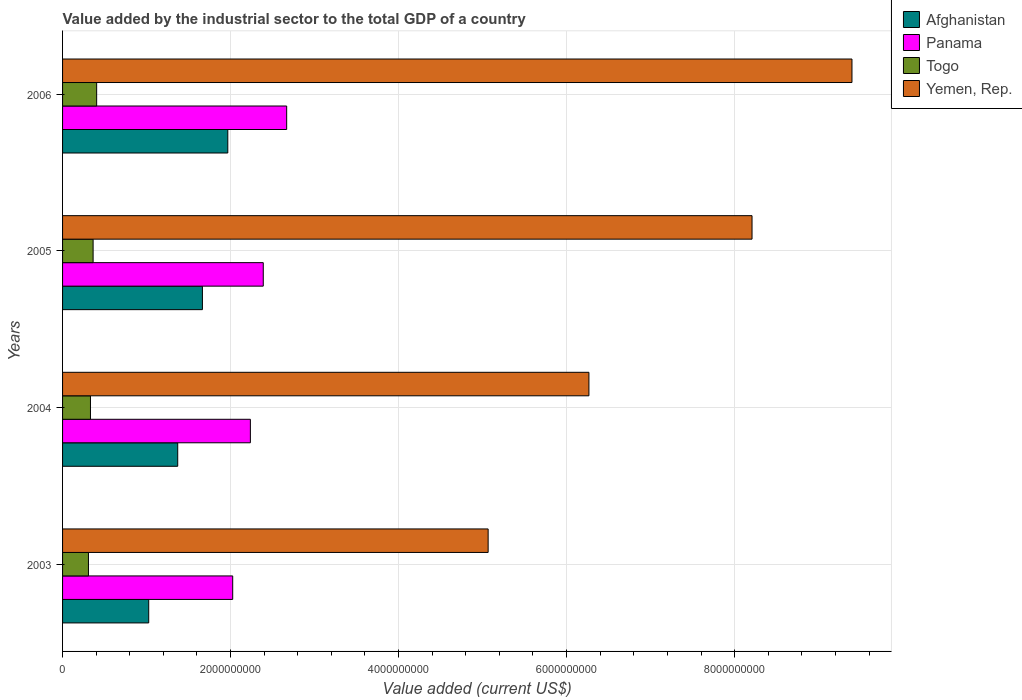What is the value added by the industrial sector to the total GDP in Yemen, Rep. in 2006?
Your answer should be very brief. 9.40e+09. Across all years, what is the maximum value added by the industrial sector to the total GDP in Afghanistan?
Make the answer very short. 1.97e+09. Across all years, what is the minimum value added by the industrial sector to the total GDP in Togo?
Keep it short and to the point. 3.08e+08. In which year was the value added by the industrial sector to the total GDP in Afghanistan minimum?
Keep it short and to the point. 2003. What is the total value added by the industrial sector to the total GDP in Afghanistan in the graph?
Provide a short and direct response. 6.03e+09. What is the difference between the value added by the industrial sector to the total GDP in Afghanistan in 2004 and that in 2005?
Offer a terse response. -2.94e+08. What is the difference between the value added by the industrial sector to the total GDP in Afghanistan in 2004 and the value added by the industrial sector to the total GDP in Togo in 2003?
Ensure brevity in your answer.  1.06e+09. What is the average value added by the industrial sector to the total GDP in Panama per year?
Your answer should be compact. 2.33e+09. In the year 2004, what is the difference between the value added by the industrial sector to the total GDP in Yemen, Rep. and value added by the industrial sector to the total GDP in Togo?
Make the answer very short. 5.93e+09. In how many years, is the value added by the industrial sector to the total GDP in Afghanistan greater than 9200000000 US$?
Make the answer very short. 0. What is the ratio of the value added by the industrial sector to the total GDP in Togo in 2003 to that in 2006?
Provide a succinct answer. 0.76. What is the difference between the highest and the second highest value added by the industrial sector to the total GDP in Afghanistan?
Your answer should be compact. 3.02e+08. What is the difference between the highest and the lowest value added by the industrial sector to the total GDP in Afghanistan?
Give a very brief answer. 9.41e+08. Is the sum of the value added by the industrial sector to the total GDP in Togo in 2003 and 2006 greater than the maximum value added by the industrial sector to the total GDP in Yemen, Rep. across all years?
Offer a terse response. No. Is it the case that in every year, the sum of the value added by the industrial sector to the total GDP in Panama and value added by the industrial sector to the total GDP in Afghanistan is greater than the sum of value added by the industrial sector to the total GDP in Yemen, Rep. and value added by the industrial sector to the total GDP in Togo?
Provide a succinct answer. Yes. What does the 3rd bar from the top in 2003 represents?
Make the answer very short. Panama. What does the 1st bar from the bottom in 2006 represents?
Provide a short and direct response. Afghanistan. Are the values on the major ticks of X-axis written in scientific E-notation?
Provide a succinct answer. No. Does the graph contain any zero values?
Your response must be concise. No. How are the legend labels stacked?
Keep it short and to the point. Vertical. What is the title of the graph?
Offer a terse response. Value added by the industrial sector to the total GDP of a country. What is the label or title of the X-axis?
Provide a succinct answer. Value added (current US$). What is the Value added (current US$) in Afghanistan in 2003?
Ensure brevity in your answer.  1.03e+09. What is the Value added (current US$) of Panama in 2003?
Offer a terse response. 2.03e+09. What is the Value added (current US$) in Togo in 2003?
Make the answer very short. 3.08e+08. What is the Value added (current US$) in Yemen, Rep. in 2003?
Your response must be concise. 5.07e+09. What is the Value added (current US$) of Afghanistan in 2004?
Provide a succinct answer. 1.37e+09. What is the Value added (current US$) in Panama in 2004?
Make the answer very short. 2.24e+09. What is the Value added (current US$) of Togo in 2004?
Provide a succinct answer. 3.32e+08. What is the Value added (current US$) of Yemen, Rep. in 2004?
Give a very brief answer. 6.27e+09. What is the Value added (current US$) in Afghanistan in 2005?
Provide a succinct answer. 1.66e+09. What is the Value added (current US$) in Panama in 2005?
Give a very brief answer. 2.39e+09. What is the Value added (current US$) in Togo in 2005?
Provide a short and direct response. 3.64e+08. What is the Value added (current US$) in Yemen, Rep. in 2005?
Your response must be concise. 8.21e+09. What is the Value added (current US$) of Afghanistan in 2006?
Your answer should be compact. 1.97e+09. What is the Value added (current US$) of Panama in 2006?
Provide a short and direct response. 2.67e+09. What is the Value added (current US$) of Togo in 2006?
Your response must be concise. 4.06e+08. What is the Value added (current US$) in Yemen, Rep. in 2006?
Make the answer very short. 9.40e+09. Across all years, what is the maximum Value added (current US$) of Afghanistan?
Offer a terse response. 1.97e+09. Across all years, what is the maximum Value added (current US$) of Panama?
Offer a very short reply. 2.67e+09. Across all years, what is the maximum Value added (current US$) of Togo?
Your answer should be compact. 4.06e+08. Across all years, what is the maximum Value added (current US$) of Yemen, Rep.?
Your answer should be compact. 9.40e+09. Across all years, what is the minimum Value added (current US$) of Afghanistan?
Provide a short and direct response. 1.03e+09. Across all years, what is the minimum Value added (current US$) of Panama?
Ensure brevity in your answer.  2.03e+09. Across all years, what is the minimum Value added (current US$) of Togo?
Provide a short and direct response. 3.08e+08. Across all years, what is the minimum Value added (current US$) in Yemen, Rep.?
Your answer should be compact. 5.07e+09. What is the total Value added (current US$) in Afghanistan in the graph?
Your response must be concise. 6.03e+09. What is the total Value added (current US$) of Panama in the graph?
Make the answer very short. 9.32e+09. What is the total Value added (current US$) of Togo in the graph?
Provide a succinct answer. 1.41e+09. What is the total Value added (current US$) of Yemen, Rep. in the graph?
Provide a short and direct response. 2.89e+1. What is the difference between the Value added (current US$) of Afghanistan in 2003 and that in 2004?
Keep it short and to the point. -3.45e+08. What is the difference between the Value added (current US$) of Panama in 2003 and that in 2004?
Your answer should be compact. -2.10e+08. What is the difference between the Value added (current US$) in Togo in 2003 and that in 2004?
Your answer should be very brief. -2.40e+07. What is the difference between the Value added (current US$) of Yemen, Rep. in 2003 and that in 2004?
Make the answer very short. -1.20e+09. What is the difference between the Value added (current US$) of Afghanistan in 2003 and that in 2005?
Provide a short and direct response. -6.39e+08. What is the difference between the Value added (current US$) of Panama in 2003 and that in 2005?
Provide a short and direct response. -3.64e+08. What is the difference between the Value added (current US$) in Togo in 2003 and that in 2005?
Give a very brief answer. -5.54e+07. What is the difference between the Value added (current US$) in Yemen, Rep. in 2003 and that in 2005?
Your response must be concise. -3.14e+09. What is the difference between the Value added (current US$) of Afghanistan in 2003 and that in 2006?
Give a very brief answer. -9.41e+08. What is the difference between the Value added (current US$) of Panama in 2003 and that in 2006?
Your answer should be very brief. -6.42e+08. What is the difference between the Value added (current US$) of Togo in 2003 and that in 2006?
Keep it short and to the point. -9.77e+07. What is the difference between the Value added (current US$) in Yemen, Rep. in 2003 and that in 2006?
Your answer should be compact. -4.33e+09. What is the difference between the Value added (current US$) in Afghanistan in 2004 and that in 2005?
Your answer should be compact. -2.94e+08. What is the difference between the Value added (current US$) in Panama in 2004 and that in 2005?
Give a very brief answer. -1.53e+08. What is the difference between the Value added (current US$) in Togo in 2004 and that in 2005?
Provide a succinct answer. -3.14e+07. What is the difference between the Value added (current US$) in Yemen, Rep. in 2004 and that in 2005?
Keep it short and to the point. -1.94e+09. What is the difference between the Value added (current US$) in Afghanistan in 2004 and that in 2006?
Make the answer very short. -5.96e+08. What is the difference between the Value added (current US$) in Panama in 2004 and that in 2006?
Provide a short and direct response. -4.32e+08. What is the difference between the Value added (current US$) of Togo in 2004 and that in 2006?
Keep it short and to the point. -7.37e+07. What is the difference between the Value added (current US$) in Yemen, Rep. in 2004 and that in 2006?
Keep it short and to the point. -3.13e+09. What is the difference between the Value added (current US$) in Afghanistan in 2005 and that in 2006?
Offer a terse response. -3.02e+08. What is the difference between the Value added (current US$) in Panama in 2005 and that in 2006?
Provide a short and direct response. -2.79e+08. What is the difference between the Value added (current US$) in Togo in 2005 and that in 2006?
Keep it short and to the point. -4.22e+07. What is the difference between the Value added (current US$) in Yemen, Rep. in 2005 and that in 2006?
Ensure brevity in your answer.  -1.19e+09. What is the difference between the Value added (current US$) in Afghanistan in 2003 and the Value added (current US$) in Panama in 2004?
Your response must be concise. -1.21e+09. What is the difference between the Value added (current US$) of Afghanistan in 2003 and the Value added (current US$) of Togo in 2004?
Your response must be concise. 6.93e+08. What is the difference between the Value added (current US$) of Afghanistan in 2003 and the Value added (current US$) of Yemen, Rep. in 2004?
Make the answer very short. -5.24e+09. What is the difference between the Value added (current US$) of Panama in 2003 and the Value added (current US$) of Togo in 2004?
Your answer should be compact. 1.69e+09. What is the difference between the Value added (current US$) of Panama in 2003 and the Value added (current US$) of Yemen, Rep. in 2004?
Provide a short and direct response. -4.24e+09. What is the difference between the Value added (current US$) of Togo in 2003 and the Value added (current US$) of Yemen, Rep. in 2004?
Offer a terse response. -5.96e+09. What is the difference between the Value added (current US$) of Afghanistan in 2003 and the Value added (current US$) of Panama in 2005?
Provide a succinct answer. -1.36e+09. What is the difference between the Value added (current US$) in Afghanistan in 2003 and the Value added (current US$) in Togo in 2005?
Offer a terse response. 6.62e+08. What is the difference between the Value added (current US$) in Afghanistan in 2003 and the Value added (current US$) in Yemen, Rep. in 2005?
Offer a terse response. -7.18e+09. What is the difference between the Value added (current US$) of Panama in 2003 and the Value added (current US$) of Togo in 2005?
Your response must be concise. 1.66e+09. What is the difference between the Value added (current US$) of Panama in 2003 and the Value added (current US$) of Yemen, Rep. in 2005?
Your answer should be compact. -6.18e+09. What is the difference between the Value added (current US$) of Togo in 2003 and the Value added (current US$) of Yemen, Rep. in 2005?
Give a very brief answer. -7.90e+09. What is the difference between the Value added (current US$) of Afghanistan in 2003 and the Value added (current US$) of Panama in 2006?
Your response must be concise. -1.64e+09. What is the difference between the Value added (current US$) in Afghanistan in 2003 and the Value added (current US$) in Togo in 2006?
Give a very brief answer. 6.20e+08. What is the difference between the Value added (current US$) of Afghanistan in 2003 and the Value added (current US$) of Yemen, Rep. in 2006?
Offer a terse response. -8.37e+09. What is the difference between the Value added (current US$) in Panama in 2003 and the Value added (current US$) in Togo in 2006?
Your response must be concise. 1.62e+09. What is the difference between the Value added (current US$) in Panama in 2003 and the Value added (current US$) in Yemen, Rep. in 2006?
Your answer should be very brief. -7.37e+09. What is the difference between the Value added (current US$) in Togo in 2003 and the Value added (current US$) in Yemen, Rep. in 2006?
Make the answer very short. -9.09e+09. What is the difference between the Value added (current US$) in Afghanistan in 2004 and the Value added (current US$) in Panama in 2005?
Provide a short and direct response. -1.02e+09. What is the difference between the Value added (current US$) of Afghanistan in 2004 and the Value added (current US$) of Togo in 2005?
Ensure brevity in your answer.  1.01e+09. What is the difference between the Value added (current US$) in Afghanistan in 2004 and the Value added (current US$) in Yemen, Rep. in 2005?
Ensure brevity in your answer.  -6.84e+09. What is the difference between the Value added (current US$) in Panama in 2004 and the Value added (current US$) in Togo in 2005?
Ensure brevity in your answer.  1.87e+09. What is the difference between the Value added (current US$) in Panama in 2004 and the Value added (current US$) in Yemen, Rep. in 2005?
Make the answer very short. -5.97e+09. What is the difference between the Value added (current US$) of Togo in 2004 and the Value added (current US$) of Yemen, Rep. in 2005?
Make the answer very short. -7.88e+09. What is the difference between the Value added (current US$) in Afghanistan in 2004 and the Value added (current US$) in Panama in 2006?
Provide a succinct answer. -1.30e+09. What is the difference between the Value added (current US$) of Afghanistan in 2004 and the Value added (current US$) of Togo in 2006?
Keep it short and to the point. 9.65e+08. What is the difference between the Value added (current US$) of Afghanistan in 2004 and the Value added (current US$) of Yemen, Rep. in 2006?
Your answer should be very brief. -8.03e+09. What is the difference between the Value added (current US$) in Panama in 2004 and the Value added (current US$) in Togo in 2006?
Offer a very short reply. 1.83e+09. What is the difference between the Value added (current US$) of Panama in 2004 and the Value added (current US$) of Yemen, Rep. in 2006?
Provide a short and direct response. -7.16e+09. What is the difference between the Value added (current US$) in Togo in 2004 and the Value added (current US$) in Yemen, Rep. in 2006?
Your answer should be very brief. -9.07e+09. What is the difference between the Value added (current US$) of Afghanistan in 2005 and the Value added (current US$) of Panama in 2006?
Offer a terse response. -1.00e+09. What is the difference between the Value added (current US$) of Afghanistan in 2005 and the Value added (current US$) of Togo in 2006?
Offer a very short reply. 1.26e+09. What is the difference between the Value added (current US$) in Afghanistan in 2005 and the Value added (current US$) in Yemen, Rep. in 2006?
Provide a succinct answer. -7.73e+09. What is the difference between the Value added (current US$) of Panama in 2005 and the Value added (current US$) of Togo in 2006?
Offer a very short reply. 1.98e+09. What is the difference between the Value added (current US$) in Panama in 2005 and the Value added (current US$) in Yemen, Rep. in 2006?
Your answer should be compact. -7.01e+09. What is the difference between the Value added (current US$) in Togo in 2005 and the Value added (current US$) in Yemen, Rep. in 2006?
Your answer should be compact. -9.03e+09. What is the average Value added (current US$) of Afghanistan per year?
Your answer should be very brief. 1.51e+09. What is the average Value added (current US$) in Panama per year?
Provide a succinct answer. 2.33e+09. What is the average Value added (current US$) of Togo per year?
Give a very brief answer. 3.52e+08. What is the average Value added (current US$) of Yemen, Rep. per year?
Offer a very short reply. 7.23e+09. In the year 2003, what is the difference between the Value added (current US$) in Afghanistan and Value added (current US$) in Panama?
Offer a very short reply. -1.00e+09. In the year 2003, what is the difference between the Value added (current US$) of Afghanistan and Value added (current US$) of Togo?
Keep it short and to the point. 7.17e+08. In the year 2003, what is the difference between the Value added (current US$) in Afghanistan and Value added (current US$) in Yemen, Rep.?
Keep it short and to the point. -4.04e+09. In the year 2003, what is the difference between the Value added (current US$) of Panama and Value added (current US$) of Togo?
Your answer should be compact. 1.72e+09. In the year 2003, what is the difference between the Value added (current US$) of Panama and Value added (current US$) of Yemen, Rep.?
Your answer should be very brief. -3.04e+09. In the year 2003, what is the difference between the Value added (current US$) of Togo and Value added (current US$) of Yemen, Rep.?
Offer a terse response. -4.76e+09. In the year 2004, what is the difference between the Value added (current US$) of Afghanistan and Value added (current US$) of Panama?
Make the answer very short. -8.65e+08. In the year 2004, what is the difference between the Value added (current US$) of Afghanistan and Value added (current US$) of Togo?
Provide a short and direct response. 1.04e+09. In the year 2004, what is the difference between the Value added (current US$) of Afghanistan and Value added (current US$) of Yemen, Rep.?
Offer a very short reply. -4.90e+09. In the year 2004, what is the difference between the Value added (current US$) of Panama and Value added (current US$) of Togo?
Provide a short and direct response. 1.90e+09. In the year 2004, what is the difference between the Value added (current US$) in Panama and Value added (current US$) in Yemen, Rep.?
Ensure brevity in your answer.  -4.03e+09. In the year 2004, what is the difference between the Value added (current US$) of Togo and Value added (current US$) of Yemen, Rep.?
Ensure brevity in your answer.  -5.93e+09. In the year 2005, what is the difference between the Value added (current US$) in Afghanistan and Value added (current US$) in Panama?
Ensure brevity in your answer.  -7.24e+08. In the year 2005, what is the difference between the Value added (current US$) in Afghanistan and Value added (current US$) in Togo?
Provide a short and direct response. 1.30e+09. In the year 2005, what is the difference between the Value added (current US$) of Afghanistan and Value added (current US$) of Yemen, Rep.?
Provide a succinct answer. -6.54e+09. In the year 2005, what is the difference between the Value added (current US$) in Panama and Value added (current US$) in Togo?
Ensure brevity in your answer.  2.03e+09. In the year 2005, what is the difference between the Value added (current US$) in Panama and Value added (current US$) in Yemen, Rep.?
Your response must be concise. -5.82e+09. In the year 2005, what is the difference between the Value added (current US$) of Togo and Value added (current US$) of Yemen, Rep.?
Keep it short and to the point. -7.84e+09. In the year 2006, what is the difference between the Value added (current US$) in Afghanistan and Value added (current US$) in Panama?
Ensure brevity in your answer.  -7.01e+08. In the year 2006, what is the difference between the Value added (current US$) of Afghanistan and Value added (current US$) of Togo?
Make the answer very short. 1.56e+09. In the year 2006, what is the difference between the Value added (current US$) in Afghanistan and Value added (current US$) in Yemen, Rep.?
Offer a very short reply. -7.43e+09. In the year 2006, what is the difference between the Value added (current US$) of Panama and Value added (current US$) of Togo?
Your response must be concise. 2.26e+09. In the year 2006, what is the difference between the Value added (current US$) of Panama and Value added (current US$) of Yemen, Rep.?
Provide a short and direct response. -6.73e+09. In the year 2006, what is the difference between the Value added (current US$) of Togo and Value added (current US$) of Yemen, Rep.?
Offer a terse response. -8.99e+09. What is the ratio of the Value added (current US$) of Afghanistan in 2003 to that in 2004?
Provide a succinct answer. 0.75. What is the ratio of the Value added (current US$) in Panama in 2003 to that in 2004?
Your response must be concise. 0.91. What is the ratio of the Value added (current US$) of Togo in 2003 to that in 2004?
Provide a succinct answer. 0.93. What is the ratio of the Value added (current US$) in Yemen, Rep. in 2003 to that in 2004?
Your answer should be compact. 0.81. What is the ratio of the Value added (current US$) of Afghanistan in 2003 to that in 2005?
Offer a terse response. 0.62. What is the ratio of the Value added (current US$) in Panama in 2003 to that in 2005?
Your response must be concise. 0.85. What is the ratio of the Value added (current US$) in Togo in 2003 to that in 2005?
Give a very brief answer. 0.85. What is the ratio of the Value added (current US$) of Yemen, Rep. in 2003 to that in 2005?
Your response must be concise. 0.62. What is the ratio of the Value added (current US$) of Afghanistan in 2003 to that in 2006?
Provide a short and direct response. 0.52. What is the ratio of the Value added (current US$) of Panama in 2003 to that in 2006?
Your response must be concise. 0.76. What is the ratio of the Value added (current US$) of Togo in 2003 to that in 2006?
Give a very brief answer. 0.76. What is the ratio of the Value added (current US$) in Yemen, Rep. in 2003 to that in 2006?
Your answer should be compact. 0.54. What is the ratio of the Value added (current US$) in Afghanistan in 2004 to that in 2005?
Provide a short and direct response. 0.82. What is the ratio of the Value added (current US$) in Panama in 2004 to that in 2005?
Provide a succinct answer. 0.94. What is the ratio of the Value added (current US$) of Togo in 2004 to that in 2005?
Give a very brief answer. 0.91. What is the ratio of the Value added (current US$) of Yemen, Rep. in 2004 to that in 2005?
Offer a very short reply. 0.76. What is the ratio of the Value added (current US$) of Afghanistan in 2004 to that in 2006?
Keep it short and to the point. 0.7. What is the ratio of the Value added (current US$) in Panama in 2004 to that in 2006?
Offer a terse response. 0.84. What is the ratio of the Value added (current US$) in Togo in 2004 to that in 2006?
Give a very brief answer. 0.82. What is the ratio of the Value added (current US$) of Yemen, Rep. in 2004 to that in 2006?
Provide a short and direct response. 0.67. What is the ratio of the Value added (current US$) in Afghanistan in 2005 to that in 2006?
Your answer should be very brief. 0.85. What is the ratio of the Value added (current US$) in Panama in 2005 to that in 2006?
Make the answer very short. 0.9. What is the ratio of the Value added (current US$) of Togo in 2005 to that in 2006?
Your answer should be compact. 0.9. What is the ratio of the Value added (current US$) of Yemen, Rep. in 2005 to that in 2006?
Provide a short and direct response. 0.87. What is the difference between the highest and the second highest Value added (current US$) in Afghanistan?
Offer a very short reply. 3.02e+08. What is the difference between the highest and the second highest Value added (current US$) of Panama?
Offer a terse response. 2.79e+08. What is the difference between the highest and the second highest Value added (current US$) in Togo?
Give a very brief answer. 4.22e+07. What is the difference between the highest and the second highest Value added (current US$) in Yemen, Rep.?
Ensure brevity in your answer.  1.19e+09. What is the difference between the highest and the lowest Value added (current US$) in Afghanistan?
Give a very brief answer. 9.41e+08. What is the difference between the highest and the lowest Value added (current US$) in Panama?
Your answer should be compact. 6.42e+08. What is the difference between the highest and the lowest Value added (current US$) in Togo?
Ensure brevity in your answer.  9.77e+07. What is the difference between the highest and the lowest Value added (current US$) in Yemen, Rep.?
Your response must be concise. 4.33e+09. 